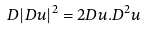Convert formula to latex. <formula><loc_0><loc_0><loc_500><loc_500>D | D u | ^ { 2 } = 2 D u . D ^ { 2 } u</formula> 